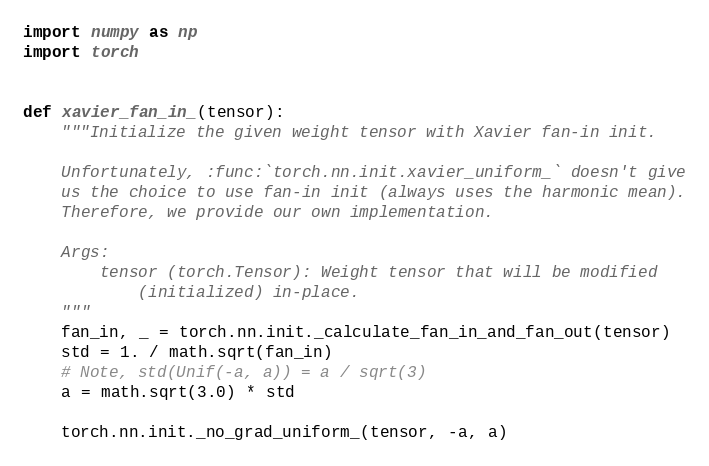<code> <loc_0><loc_0><loc_500><loc_500><_Python_>
import numpy as np
import torch


def xavier_fan_in_(tensor):
    """Initialize the given weight tensor with Xavier fan-in init.

    Unfortunately, :func:`torch.nn.init.xavier_uniform_` doesn't give
    us the choice to use fan-in init (always uses the harmonic mean).
    Therefore, we provide our own implementation.

    Args:
        tensor (torch.Tensor): Weight tensor that will be modified
            (initialized) in-place.
    """
    fan_in, _ = torch.nn.init._calculate_fan_in_and_fan_out(tensor)
    std = 1. / math.sqrt(fan_in)
    # Note, std(Unif(-a, a)) = a / sqrt(3)
    a = math.sqrt(3.0) * std

    torch.nn.init._no_grad_uniform_(tensor, -a, a)

</code> 